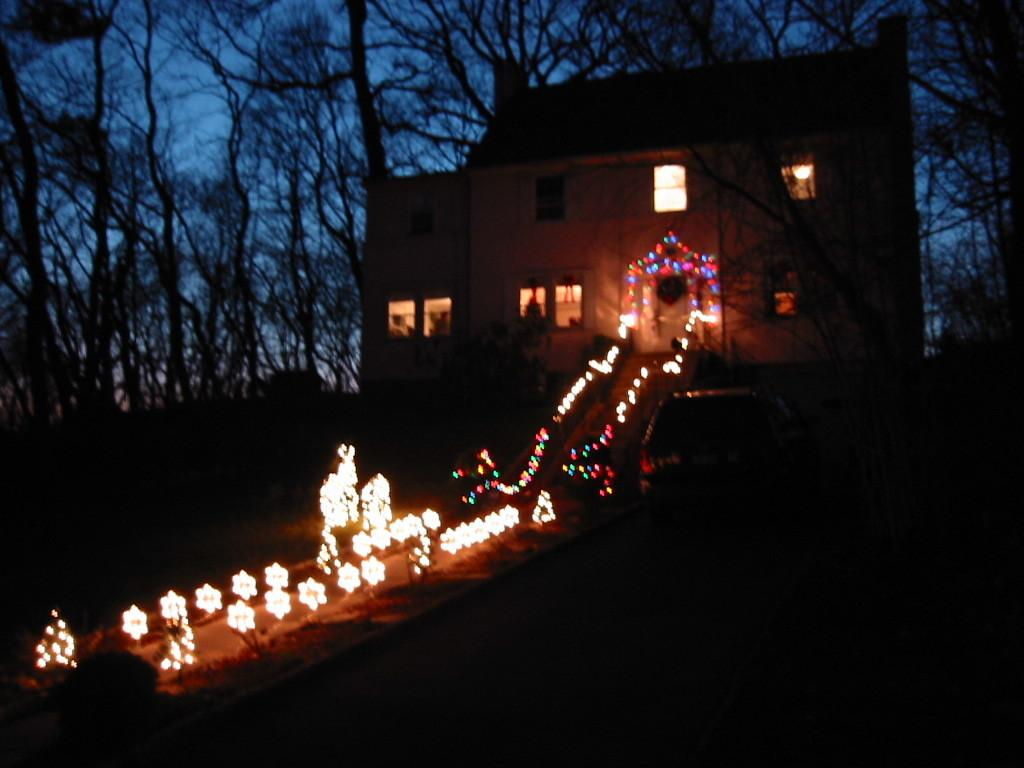What type of structure is present in the image? There is a building in the image. What can be seen illuminated in the image? There are lights visible in the image. What type of natural elements are visible in the background of the image? There are trees in the background of the image. What part of the natural environment is visible in the background of the image? The sky is visible in the background of the image. How would you describe the lighting at the bottom of the image? The bottom part of the image is dark. How does the yam contribute to the force applied to the building in the image? There is no yam present in the image, and therefore it cannot contribute to any force applied to the building. 